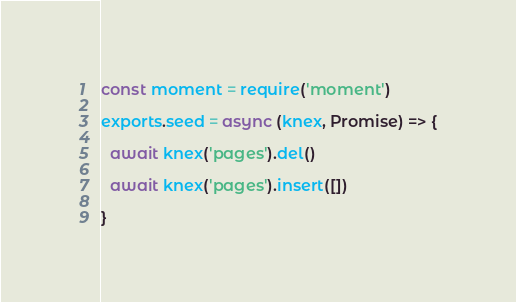Convert code to text. <code><loc_0><loc_0><loc_500><loc_500><_JavaScript_>const moment = require('moment')

exports.seed = async (knex, Promise) => {

  await knex('pages').del()

  await knex('pages').insert([])

}
</code> 